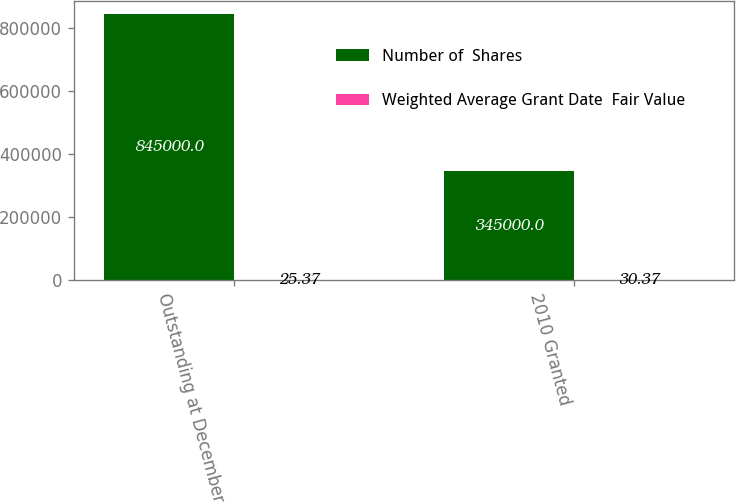<chart> <loc_0><loc_0><loc_500><loc_500><stacked_bar_chart><ecel><fcel>Outstanding at December 31<fcel>2010 Granted<nl><fcel>Number of  Shares<fcel>845000<fcel>345000<nl><fcel>Weighted Average Grant Date  Fair Value<fcel>25.37<fcel>30.37<nl></chart> 